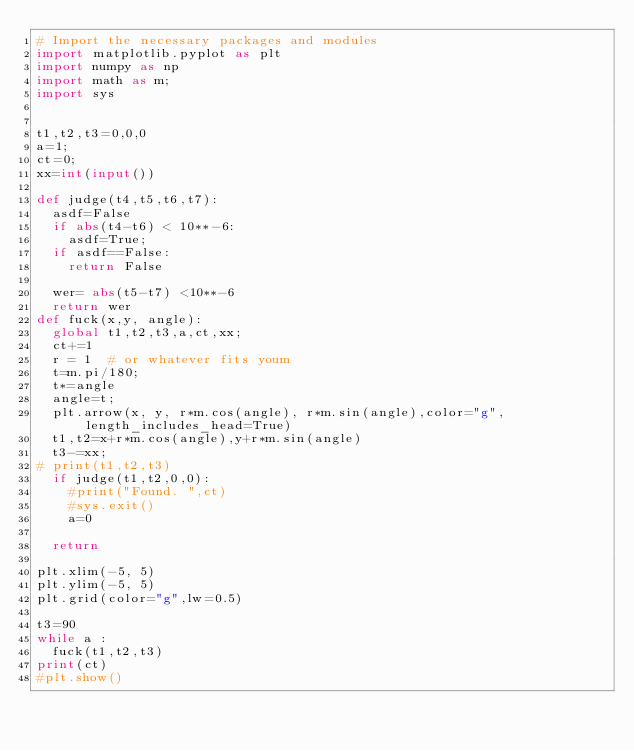<code> <loc_0><loc_0><loc_500><loc_500><_Python_># Import the necessary packages and modules
import matplotlib.pyplot as plt
import numpy as np
import math as m;
import sys


t1,t2,t3=0,0,0
a=1;
ct=0;
xx=int(input())

def judge(t4,t5,t6,t7):
	asdf=False
	if abs(t4-t6) < 10**-6:
		asdf=True;
	if asdf==False:
		return False

	wer= abs(t5-t7) <10**-6
	return wer
def fuck(x,y, angle):
	global t1,t2,t3,a,ct,xx;
	ct+=1
	r = 1  # or whatever fits youm
	t=m.pi/180;
	t*=angle
	angle=t;
	plt.arrow(x, y, r*m.cos(angle), r*m.sin(angle),color="g",length_includes_head=True)
	t1,t2=x+r*m.cos(angle),y+r*m.sin(angle)
	t3-=xx;
#	print(t1,t2,t3)
	if judge(t1,t2,0,0):
		#print("Found. ",ct)
		#sys.exit()
		a=0

	return 

plt.xlim(-5, 5)
plt.ylim(-5, 5)
plt.grid(color="g",lw=0.5)

t3=90
while a :	
	fuck(t1,t2,t3)
print(ct)
#plt.show()</code> 